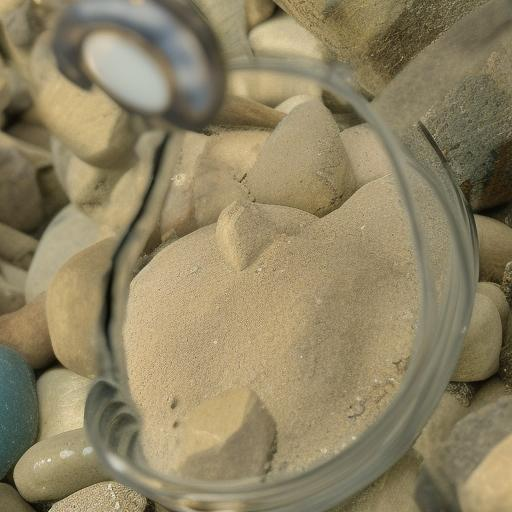Can you describe the textures in this image and how they contribute to the overall visual effect? This image showcases a rich variety of textures that create a tactile visual effect. The smooth, curving surface of the magnifying glass contrasts sharply with the rough granularity of the sand. Meanwhile, the rounded, worn surface of the pebbles offers a middle ground between the fine sand and the glass. These contrasting textures draw the eye and invite touch, even through visual means only, adding a layer of depth and interest that makes the image more engaging to explore. 